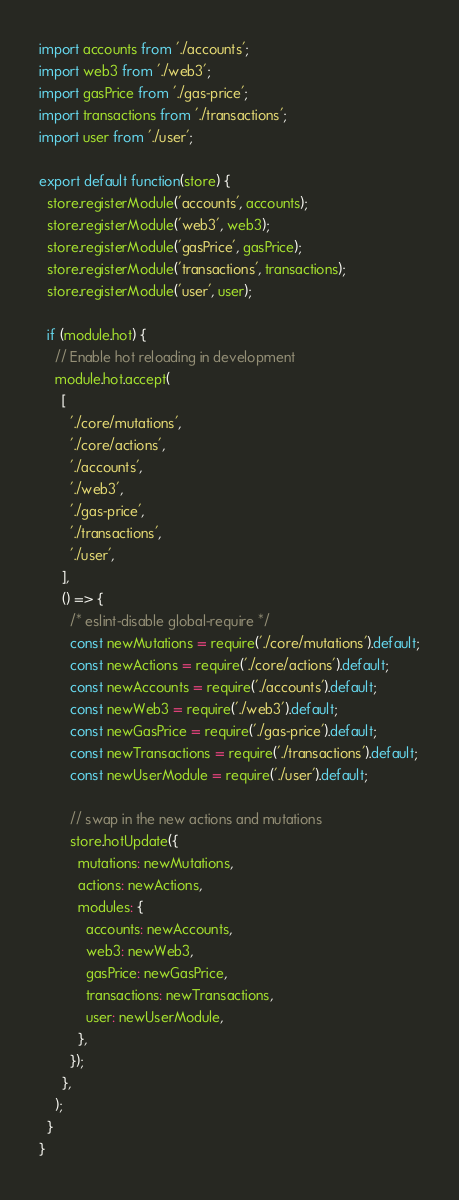Convert code to text. <code><loc_0><loc_0><loc_500><loc_500><_JavaScript_>import accounts from './accounts';
import web3 from './web3';
import gasPrice from './gas-price';
import transactions from './transactions';
import user from './user';

export default function(store) {
  store.registerModule('accounts', accounts);
  store.registerModule('web3', web3);
  store.registerModule('gasPrice', gasPrice);
  store.registerModule('transactions', transactions);
  store.registerModule('user', user);

  if (module.hot) {
    // Enable hot reloading in development
    module.hot.accept(
      [
        './core/mutations',
        './core/actions',
        './accounts',
        './web3',
        './gas-price',
        './transactions',
        './user',
      ],
      () => {
        /* eslint-disable global-require */
        const newMutations = require('./core/mutations').default;
        const newActions = require('./core/actions').default;
        const newAccounts = require('./accounts').default;
        const newWeb3 = require('./web3').default;
        const newGasPrice = require('./gas-price').default;
        const newTransactions = require('./transactions').default;
        const newUserModule = require('./user').default;

        // swap in the new actions and mutations
        store.hotUpdate({
          mutations: newMutations,
          actions: newActions,
          modules: {
            accounts: newAccounts,
            web3: newWeb3,
            gasPrice: newGasPrice,
            transactions: newTransactions,
            user: newUserModule,
          },
        });
      },
    );
  }
}
</code> 